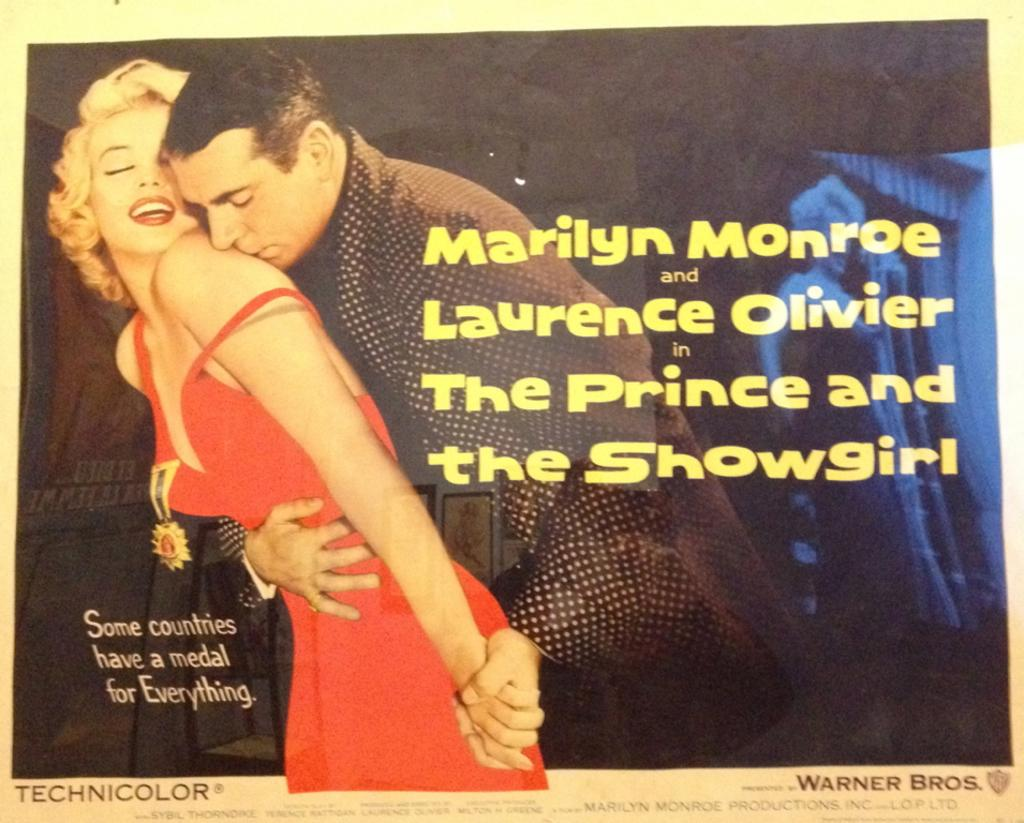What is featured on the poster in the picture? There is a poster in the picture, and it features a man and a woman. What else can be seen on the poster besides the man and woman? There is text present on the poster. Can you describe the tiger's tail on the poster? There is no tiger present on the poster; it features a man and a woman with text. 